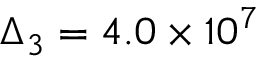Convert formula to latex. <formula><loc_0><loc_0><loc_500><loc_500>\Delta _ { 3 } = 4 . 0 \times 1 0 ^ { 7 }</formula> 